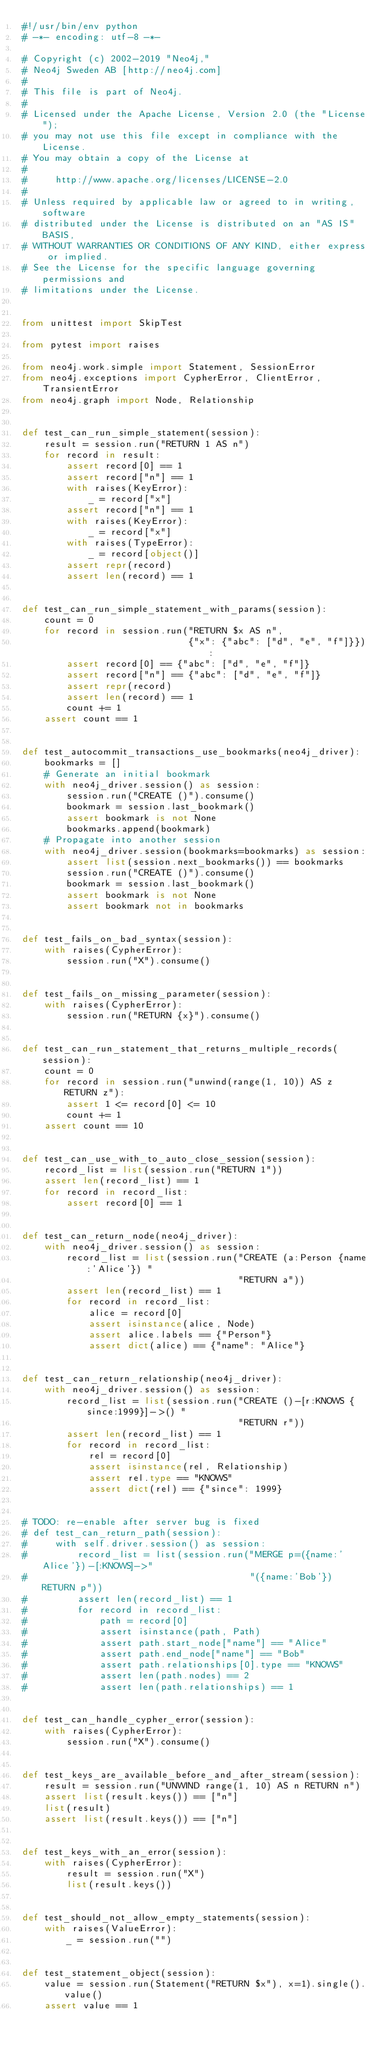Convert code to text. <code><loc_0><loc_0><loc_500><loc_500><_Python_>#!/usr/bin/env python
# -*- encoding: utf-8 -*-

# Copyright (c) 2002-2019 "Neo4j,"
# Neo4j Sweden AB [http://neo4j.com]
#
# This file is part of Neo4j.
#
# Licensed under the Apache License, Version 2.0 (the "License");
# you may not use this file except in compliance with the License.
# You may obtain a copy of the License at
#
#     http://www.apache.org/licenses/LICENSE-2.0
#
# Unless required by applicable law or agreed to in writing, software
# distributed under the License is distributed on an "AS IS" BASIS,
# WITHOUT WARRANTIES OR CONDITIONS OF ANY KIND, either express or implied.
# See the License for the specific language governing permissions and
# limitations under the License.


from unittest import SkipTest

from pytest import raises

from neo4j.work.simple import Statement, SessionError
from neo4j.exceptions import CypherError, ClientError, TransientError
from neo4j.graph import Node, Relationship


def test_can_run_simple_statement(session):
    result = session.run("RETURN 1 AS n")
    for record in result:
        assert record[0] == 1
        assert record["n"] == 1
        with raises(KeyError):
            _ = record["x"]
        assert record["n"] == 1
        with raises(KeyError):
            _ = record["x"]
        with raises(TypeError):
            _ = record[object()]
        assert repr(record)
        assert len(record) == 1


def test_can_run_simple_statement_with_params(session):
    count = 0
    for record in session.run("RETURN $x AS n",
                              {"x": {"abc": ["d", "e", "f"]}}):
        assert record[0] == {"abc": ["d", "e", "f"]}
        assert record["n"] == {"abc": ["d", "e", "f"]}
        assert repr(record)
        assert len(record) == 1
        count += 1
    assert count == 1


def test_autocommit_transactions_use_bookmarks(neo4j_driver):
    bookmarks = []
    # Generate an initial bookmark
    with neo4j_driver.session() as session:
        session.run("CREATE ()").consume()
        bookmark = session.last_bookmark()
        assert bookmark is not None
        bookmarks.append(bookmark)
    # Propagate into another session
    with neo4j_driver.session(bookmarks=bookmarks) as session:
        assert list(session.next_bookmarks()) == bookmarks
        session.run("CREATE ()").consume()
        bookmark = session.last_bookmark()
        assert bookmark is not None
        assert bookmark not in bookmarks


def test_fails_on_bad_syntax(session):
    with raises(CypherError):
        session.run("X").consume()


def test_fails_on_missing_parameter(session):
    with raises(CypherError):
        session.run("RETURN {x}").consume()


def test_can_run_statement_that_returns_multiple_records(session):
    count = 0
    for record in session.run("unwind(range(1, 10)) AS z RETURN z"):
        assert 1 <= record[0] <= 10
        count += 1
    assert count == 10


def test_can_use_with_to_auto_close_session(session):
    record_list = list(session.run("RETURN 1"))
    assert len(record_list) == 1
    for record in record_list:
        assert record[0] == 1


def test_can_return_node(neo4j_driver):
    with neo4j_driver.session() as session:
        record_list = list(session.run("CREATE (a:Person {name:'Alice'}) "
                                       "RETURN a"))
        assert len(record_list) == 1
        for record in record_list:
            alice = record[0]
            assert isinstance(alice, Node)
            assert alice.labels == {"Person"}
            assert dict(alice) == {"name": "Alice"}


def test_can_return_relationship(neo4j_driver):
    with neo4j_driver.session() as session:
        record_list = list(session.run("CREATE ()-[r:KNOWS {since:1999}]->() "
                                       "RETURN r"))
        assert len(record_list) == 1
        for record in record_list:
            rel = record[0]
            assert isinstance(rel, Relationship)
            assert rel.type == "KNOWS"
            assert dict(rel) == {"since": 1999}


# TODO: re-enable after server bug is fixed
# def test_can_return_path(session):
#     with self.driver.session() as session:
#         record_list = list(session.run("MERGE p=({name:'Alice'})-[:KNOWS]->"
#                                        "({name:'Bob'}) RETURN p"))
#         assert len(record_list) == 1
#         for record in record_list:
#             path = record[0]
#             assert isinstance(path, Path)
#             assert path.start_node["name"] == "Alice"
#             assert path.end_node["name"] == "Bob"
#             assert path.relationships[0].type == "KNOWS"
#             assert len(path.nodes) == 2
#             assert len(path.relationships) == 1


def test_can_handle_cypher_error(session):
    with raises(CypherError):
        session.run("X").consume()


def test_keys_are_available_before_and_after_stream(session):
    result = session.run("UNWIND range(1, 10) AS n RETURN n")
    assert list(result.keys()) == ["n"]
    list(result)
    assert list(result.keys()) == ["n"]


def test_keys_with_an_error(session):
    with raises(CypherError):
        result = session.run("X")
        list(result.keys())


def test_should_not_allow_empty_statements(session):
    with raises(ValueError):
        _ = session.run("")


def test_statement_object(session):
    value = session.run(Statement("RETURN $x"), x=1).single().value()
    assert value == 1

</code> 